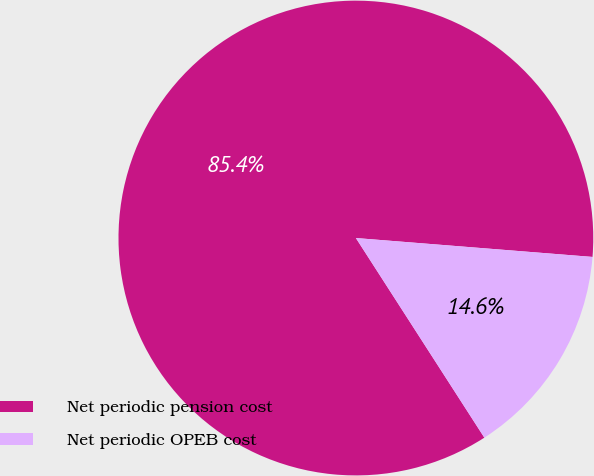Convert chart to OTSL. <chart><loc_0><loc_0><loc_500><loc_500><pie_chart><fcel>Net periodic pension cost<fcel>Net periodic OPEB cost<nl><fcel>85.37%<fcel>14.63%<nl></chart> 